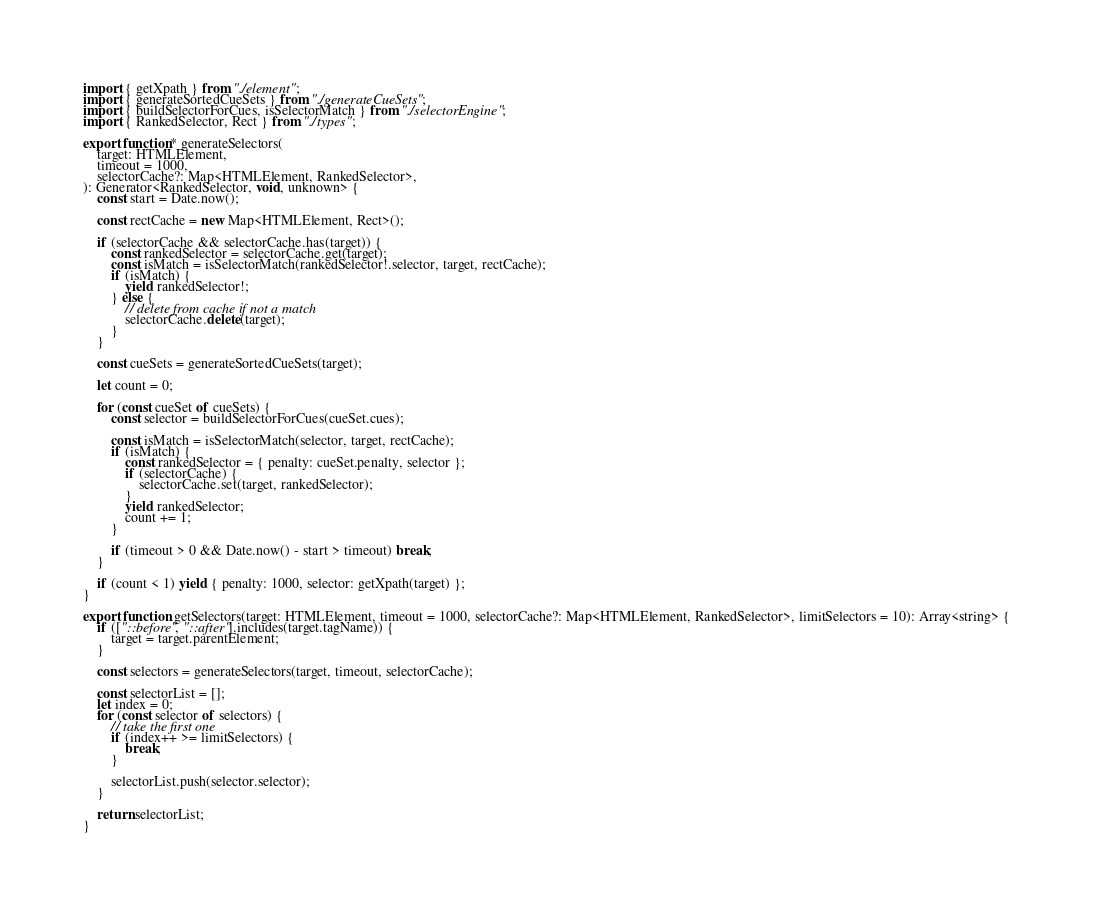<code> <loc_0><loc_0><loc_500><loc_500><_TypeScript_>import { getXpath } from "./element";
import { generateSortedCueSets } from "./generateCueSets";
import { buildSelectorForCues, isSelectorMatch } from "./selectorEngine";
import { RankedSelector, Rect } from "./types";

export function* generateSelectors(
	target: HTMLElement,
	timeout = 1000,
	selectorCache?: Map<HTMLElement, RankedSelector>,
): Generator<RankedSelector, void, unknown> {
	const start = Date.now();

	const rectCache = new Map<HTMLElement, Rect>();

	if (selectorCache && selectorCache.has(target)) {
		const rankedSelector = selectorCache.get(target);
		const isMatch = isSelectorMatch(rankedSelector!.selector, target, rectCache);
		if (isMatch) {
			yield rankedSelector!;
		} else {
			// delete from cache if not a match
			selectorCache.delete(target);
		}
	}

	const cueSets = generateSortedCueSets(target);

	let count = 0;

	for (const cueSet of cueSets) {
		const selector = buildSelectorForCues(cueSet.cues);

		const isMatch = isSelectorMatch(selector, target, rectCache);
		if (isMatch) {
			const rankedSelector = { penalty: cueSet.penalty, selector };
			if (selectorCache) {
				selectorCache.set(target, rankedSelector);
			}
			yield rankedSelector;
			count += 1;
		}

		if (timeout > 0 && Date.now() - start > timeout) break;
	}

	if (count < 1) yield { penalty: 1000, selector: getXpath(target) };
}

export function getSelectors(target: HTMLElement, timeout = 1000, selectorCache?: Map<HTMLElement, RankedSelector>, limitSelectors = 10): Array<string> {
	if (["::before", "::after"].includes(target.tagName)) {
		target = target.parentElement;
	}

	const selectors = generateSelectors(target, timeout, selectorCache);

	const selectorList = [];
	let index = 0;
	for (const selector of selectors) {
		// take the first one
		if (index++ >= limitSelectors) {
			break;
		}

		selectorList.push(selector.selector);
	}

	return selectorList;
}
</code> 